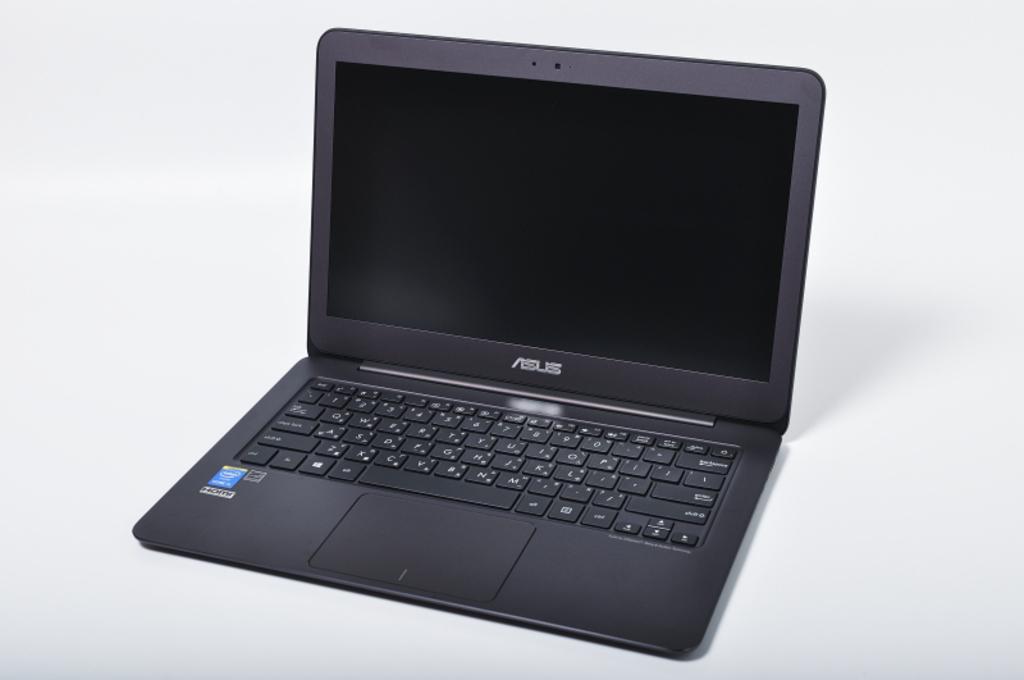What brand is the laptop?
Give a very brief answer. Asus. 